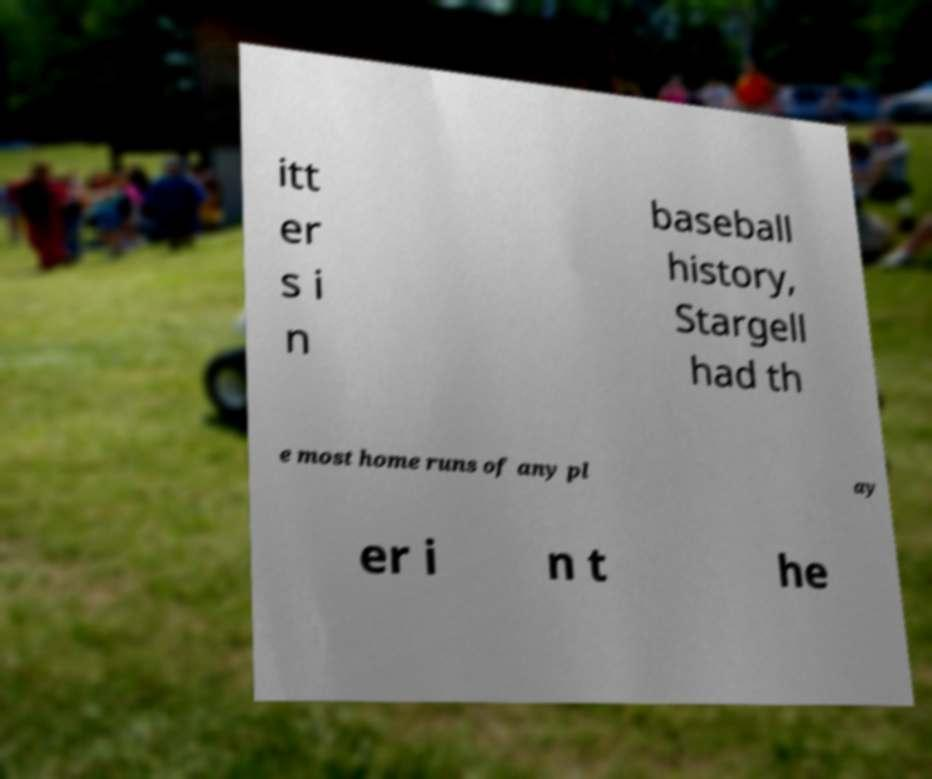Please identify and transcribe the text found in this image. itt er s i n baseball history, Stargell had th e most home runs of any pl ay er i n t he 